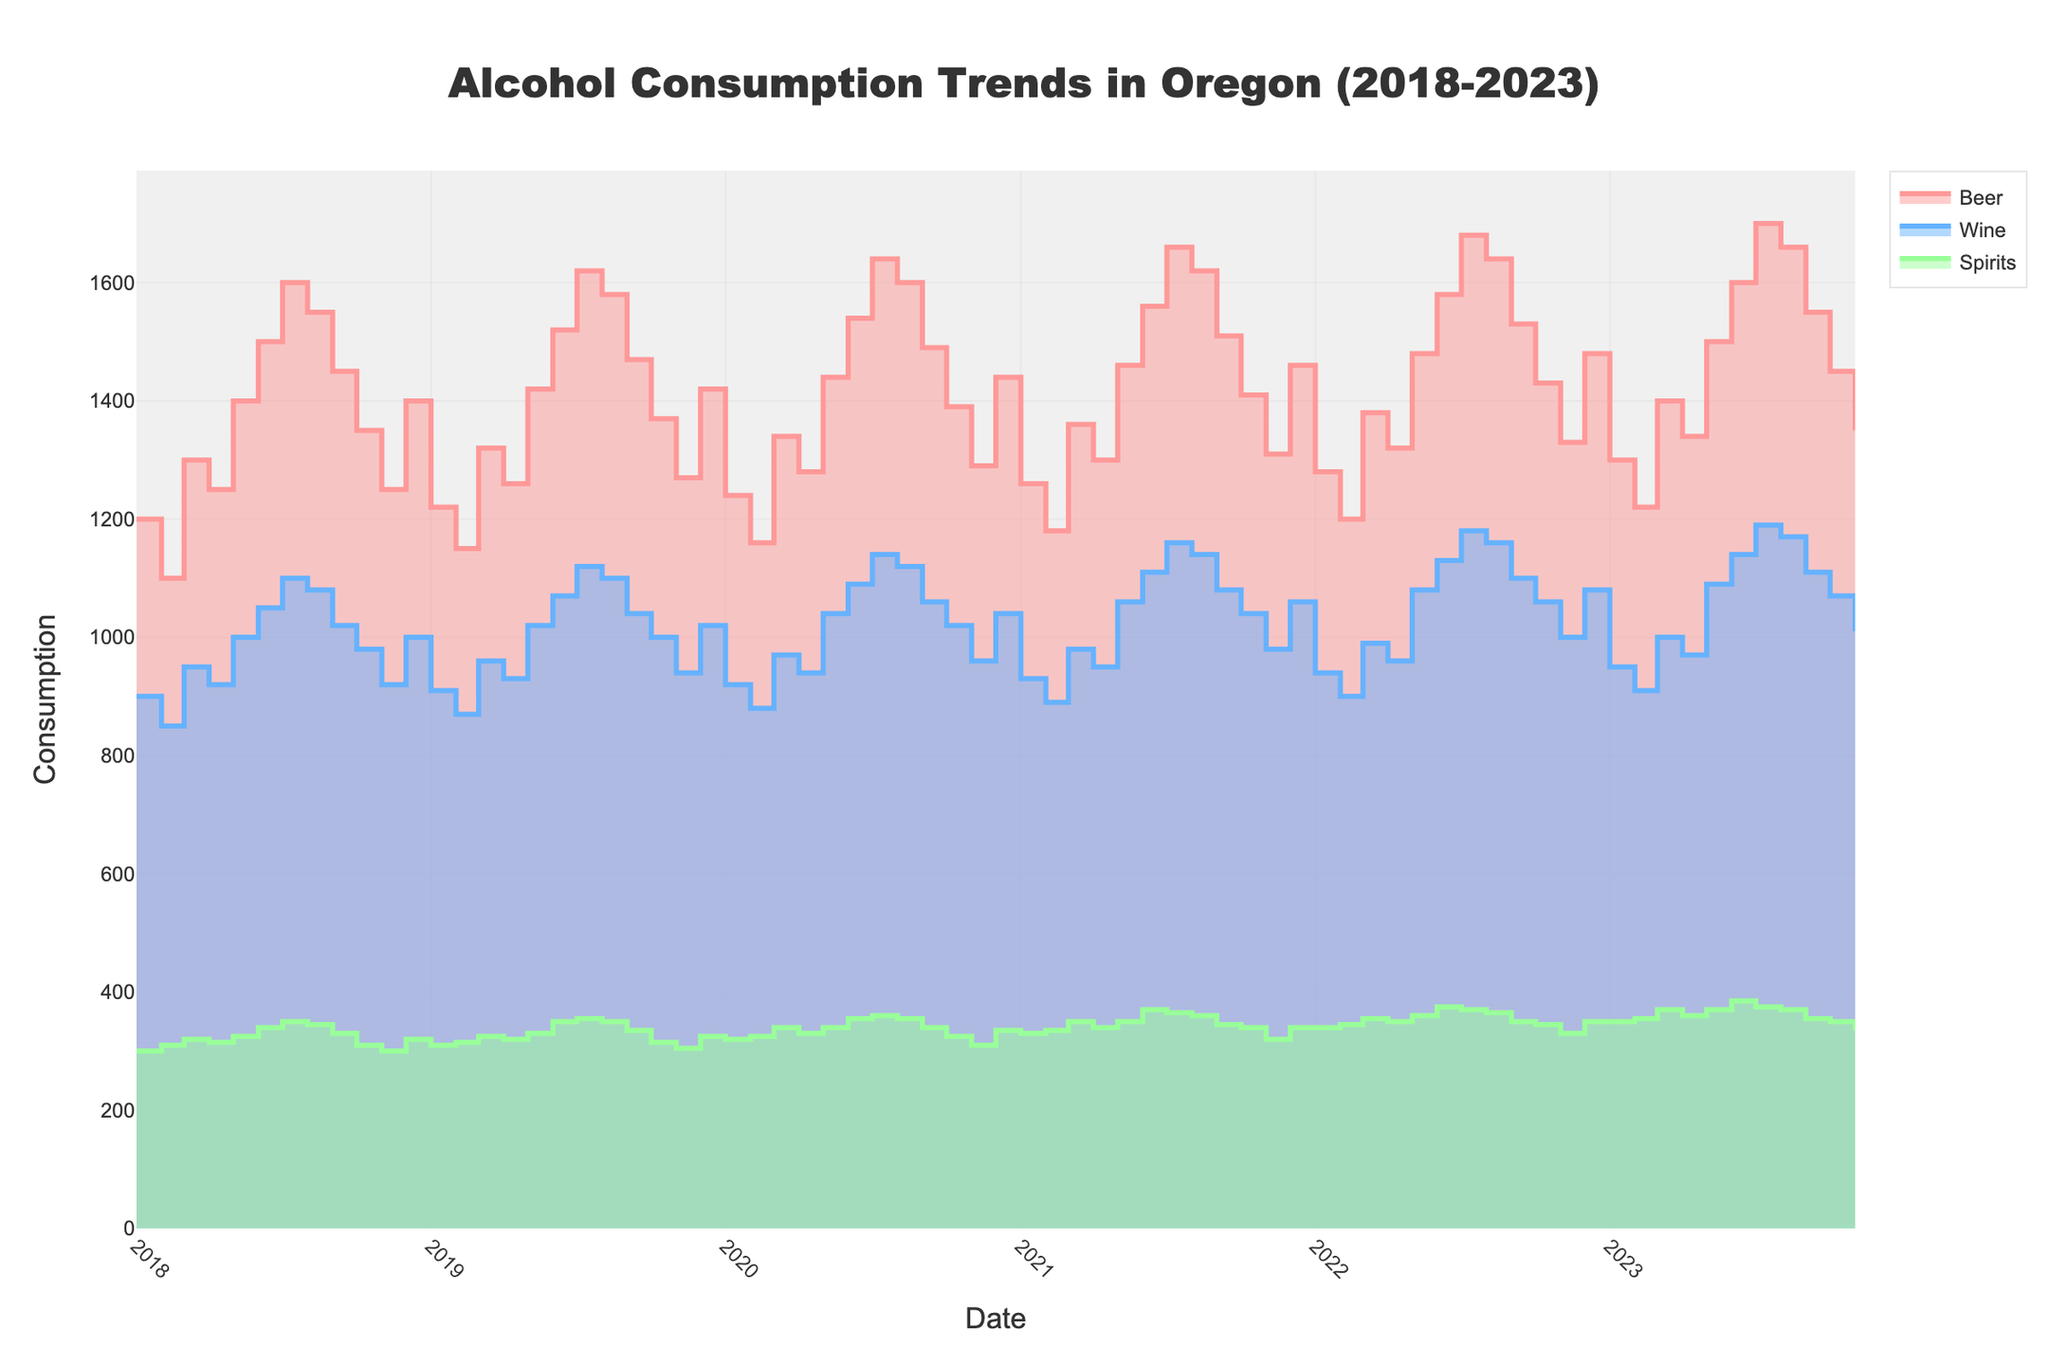What are the units of measurement for the y-axis? The y-axis represents the quantity of alcohol consumed, as indicated by the title "Consumption."
Answer: Quantity of alcohol consumed How many different types of alcohol are tracked in the figure? The figure includes three types of alcohol, as shown by the three different colored lines: Beer, Wine, and Spirits.
Answer: Three Which month had the highest beer consumption in 2023? The highest beer consumption in 2023 corresponds to the highest point on the Beer line. In July, the Beer consumption reached its peak at 1700 units.
Answer: July What is the general trend in the beer consumption over the five years? To determine the general trend, observe the Beer line from 2018 to 2023. Overall, the Beer consumption shows an increasing trend, with occasional fluctuations.
Answer: Increasing trend In which months does wine consumption typically peak each year? By looking at the highest points for Wine on the figure each year, we see that wine consumption generally peaks in July.
Answer: July Is there a specific season where spirits consumption spikes? Observing the Spirits line across multiple years, the spikes appear to occur most consistently in June and July.
Answer: June and July How does beer consumption in December 2022 compare to December 2023? Comparing the Beer values for December 2022 and December 2023, we find that in December 2022, the Beer consumption was 1480 units, while in December 2023, it was 1600 units.
Answer: Beer consumption increased What is the average monthly wine consumption in 2021? Adding the monthly wine consumption values for 2021 and dividing by 12: (930 + 890 + 980 + 950 + 1060 + 1110 + 1160 + 1140 + 1080 + 1040 + 980 + 1060) / 12 = 1027.5 units.
Answer: 1027.5 units Which type of alcohol had the largest increase from January 2018 to December 2023? Comparing the values in January 2018 and December 2023, Beer increased from 1200 to 1600 (400 units), Wine from 900 to 1070 (170 units), and Spirits from 300 to 350 (50 units). Beer had the largest increase.
Answer: Beer Does alcohol consumption peak around the same time for all types? By examining the peaks for Beer, Wine, and Spirits, we notice that they all tend to peak around June and July consistently across the years.
Answer: Yes 